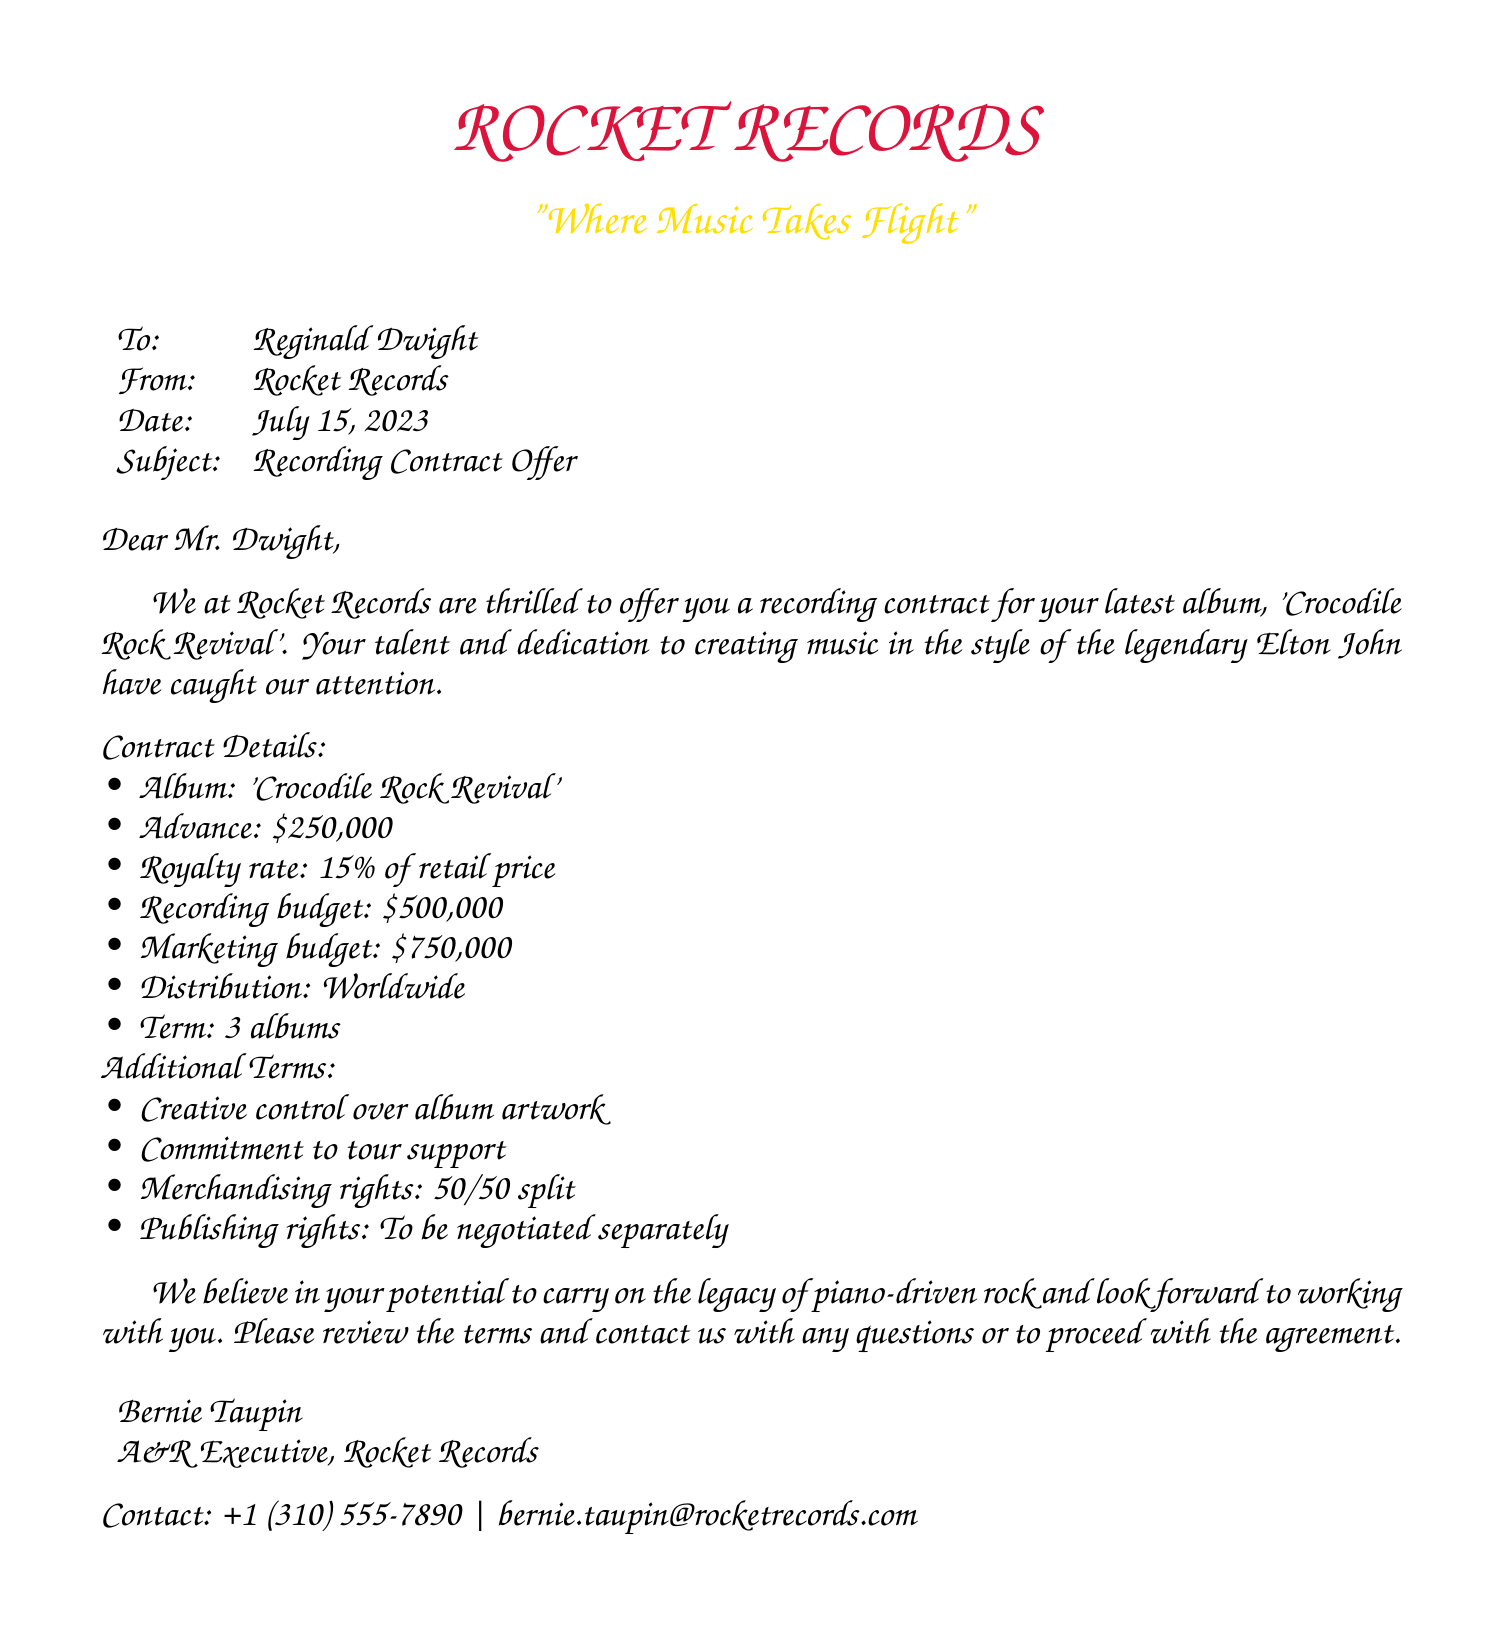What is the name of the album? The album title is clearly mentioned in the contract details section.
Answer: 'Crocodile Rock Revival' What is the advance payment? The advance payment is specified in the contract details section.
Answer: $250,000 What is the royalty rate? The royalty rate is provided among the contract details.
Answer: 15% of retail price What is the total recording budget? The total recording budget is listed in the contract details.
Answer: $500,000 How many albums is the contract for? The term of the contract specifies the number of albums.
Answer: 3 albums What are the merchandising rights split? The document states the split for merchandising rights in the additional terms.
Answer: 50/50 split Who sent the contract offer? The sender's name is mentioned at the end of the document.
Answer: Bernie Taupin What is the contact email provided in the document? The contact email is included in the signature section.
Answer: bernie.taupin@rocketrecords.com What is the purpose of the marketing budget? The document defines the purpose related to the album in the contract context.
Answer: Marketing of the album 